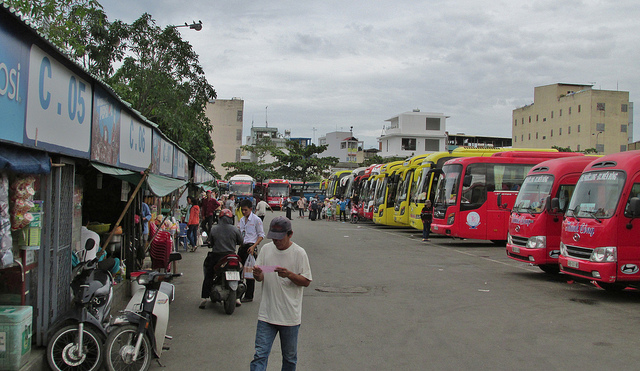<image>What does this stall sell? I am not sure what this stall sells. It could be food, bus tickets, or pepsi. What does this stall sell? I am not sure what this stall sells. It can be food, bus tickets, pepsi, chips, fruit or something else. 